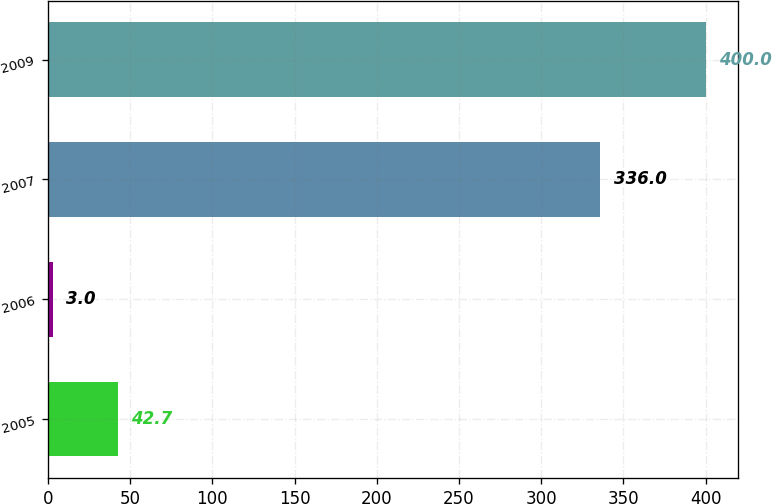Convert chart. <chart><loc_0><loc_0><loc_500><loc_500><bar_chart><fcel>2005<fcel>2006<fcel>2007<fcel>2009<nl><fcel>42.7<fcel>3<fcel>336<fcel>400<nl></chart> 